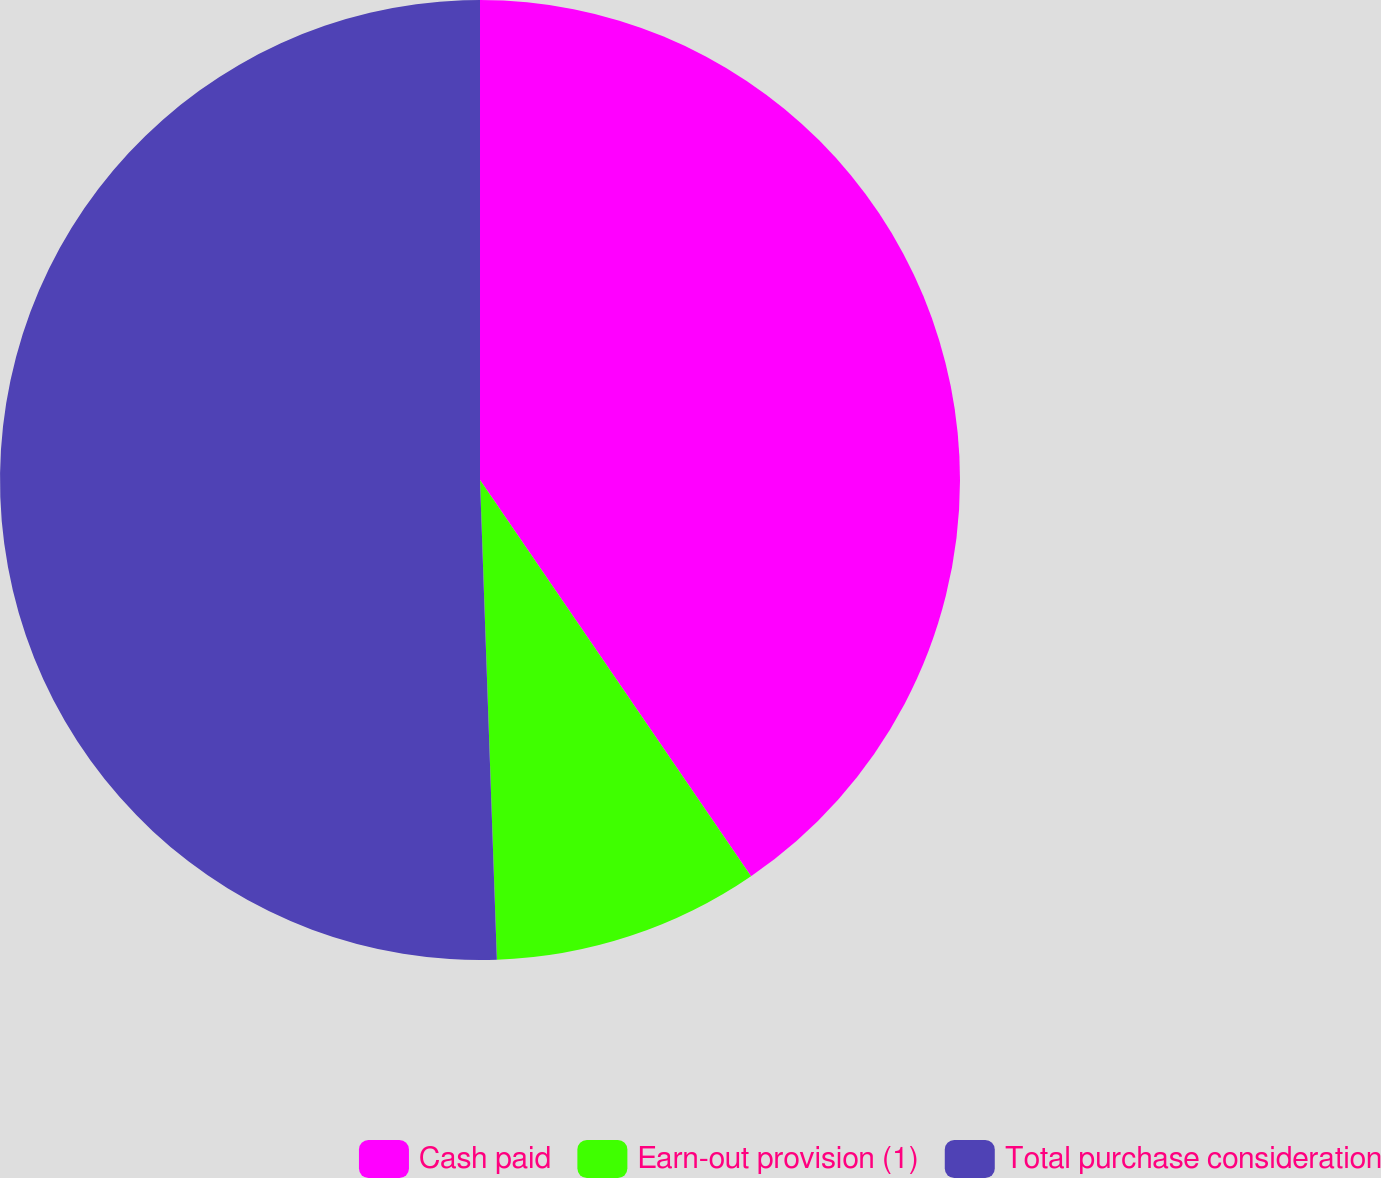Convert chart to OTSL. <chart><loc_0><loc_0><loc_500><loc_500><pie_chart><fcel>Cash paid<fcel>Earn-out provision (1)<fcel>Total purchase consideration<nl><fcel>40.45%<fcel>8.99%<fcel>50.56%<nl></chart> 